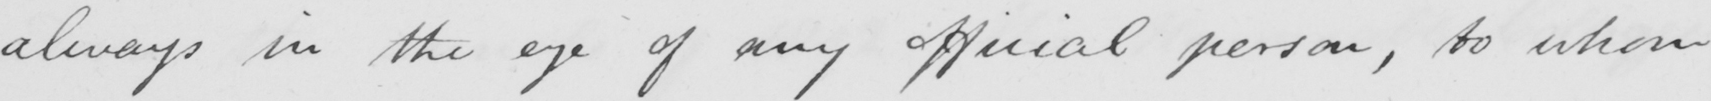What does this handwritten line say? always in the eye of any official person , to whom 